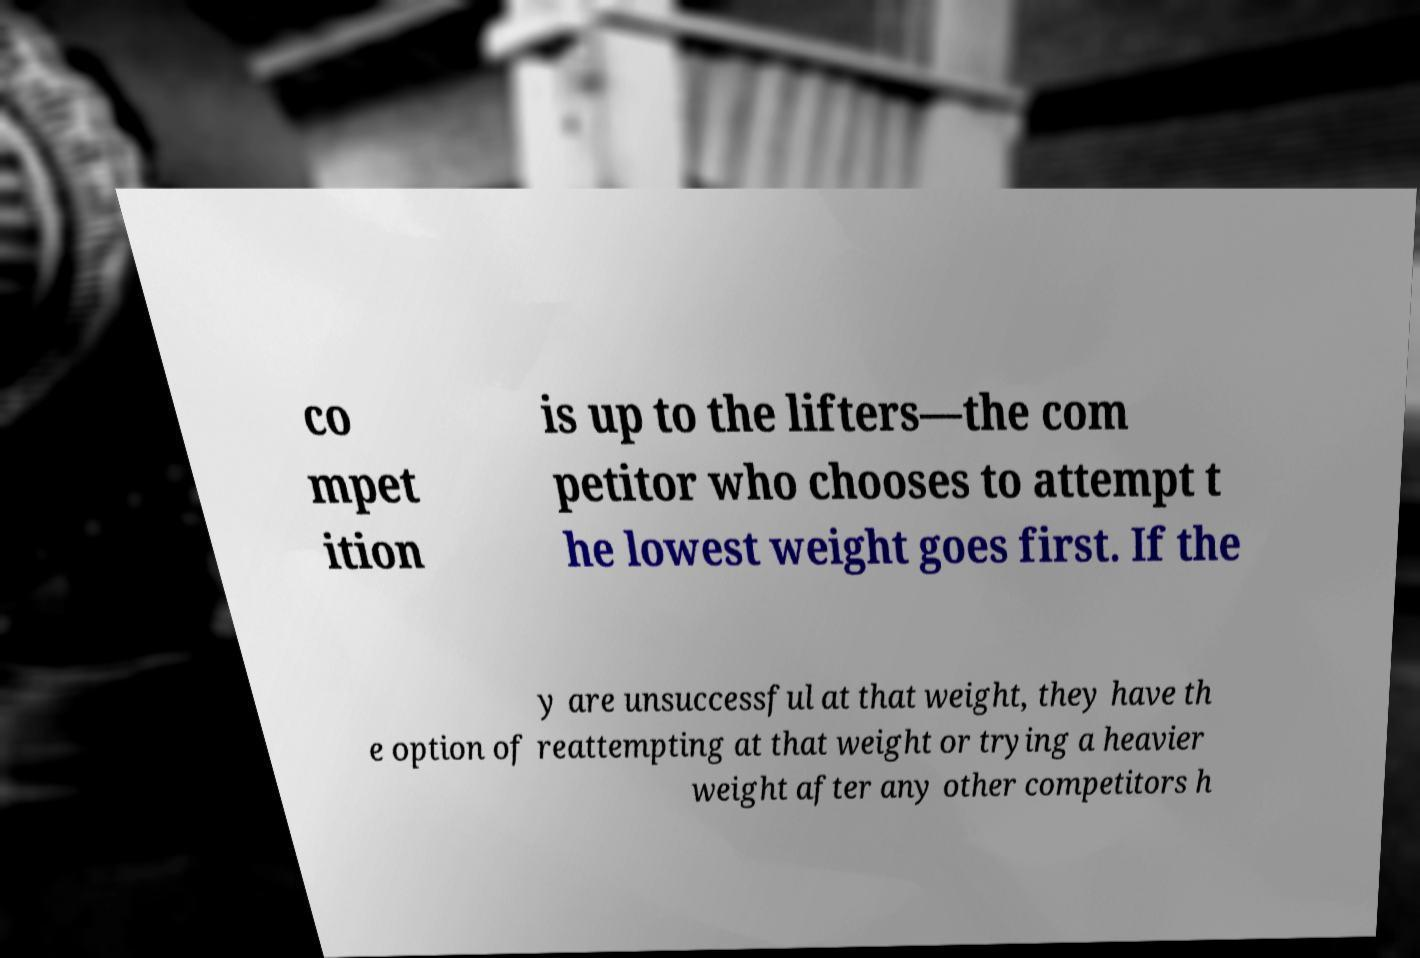What messages or text are displayed in this image? I need them in a readable, typed format. co mpet ition is up to the lifters—the com petitor who chooses to attempt t he lowest weight goes first. If the y are unsuccessful at that weight, they have th e option of reattempting at that weight or trying a heavier weight after any other competitors h 